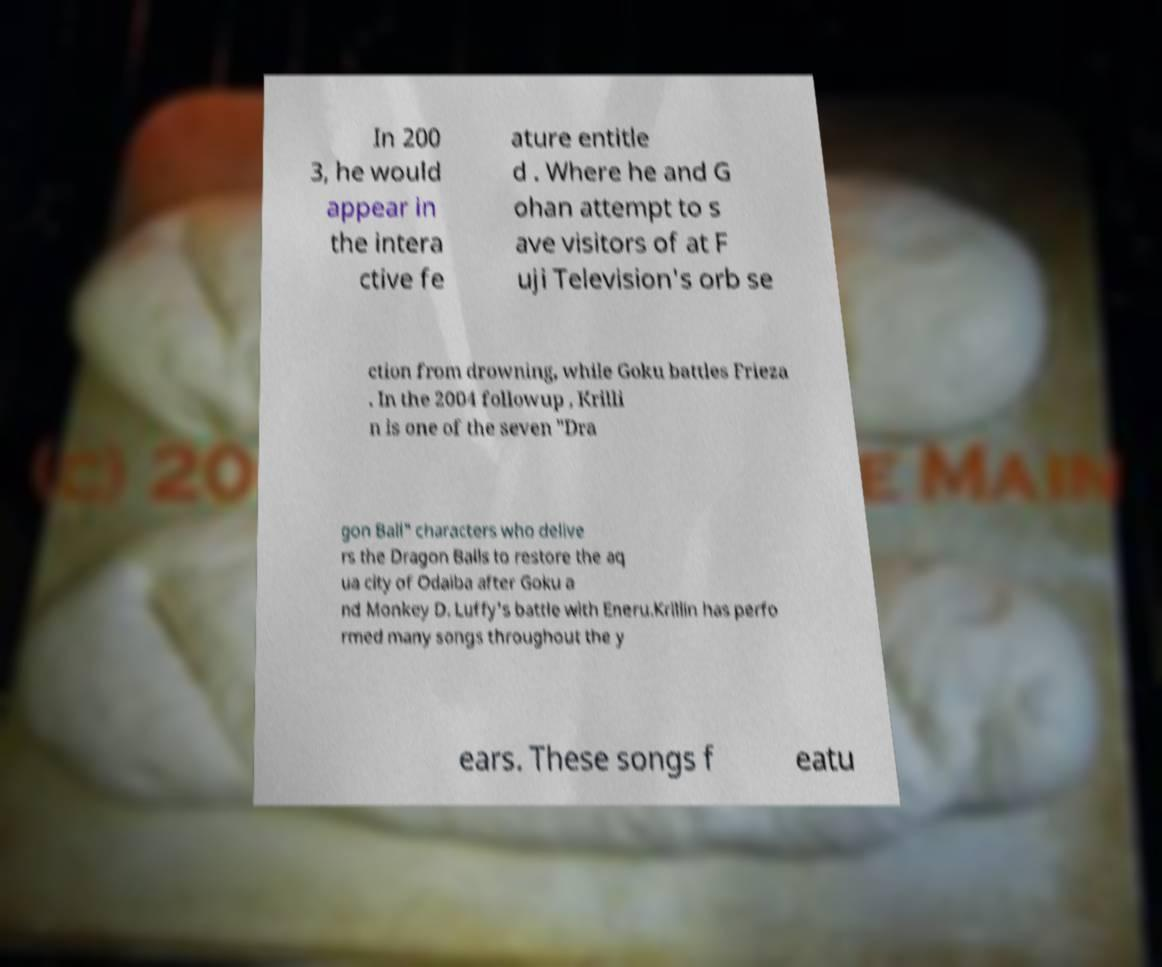Please identify and transcribe the text found in this image. In 200 3, he would appear in the intera ctive fe ature entitle d . Where he and G ohan attempt to s ave visitors of at F uji Television's orb se ction from drowning, while Goku battles Frieza . In the 2004 followup , Krilli n is one of the seven "Dra gon Ball" characters who delive rs the Dragon Balls to restore the aq ua city of Odaiba after Goku a nd Monkey D. Luffy's battle with Eneru.Krillin has perfo rmed many songs throughout the y ears. These songs f eatu 